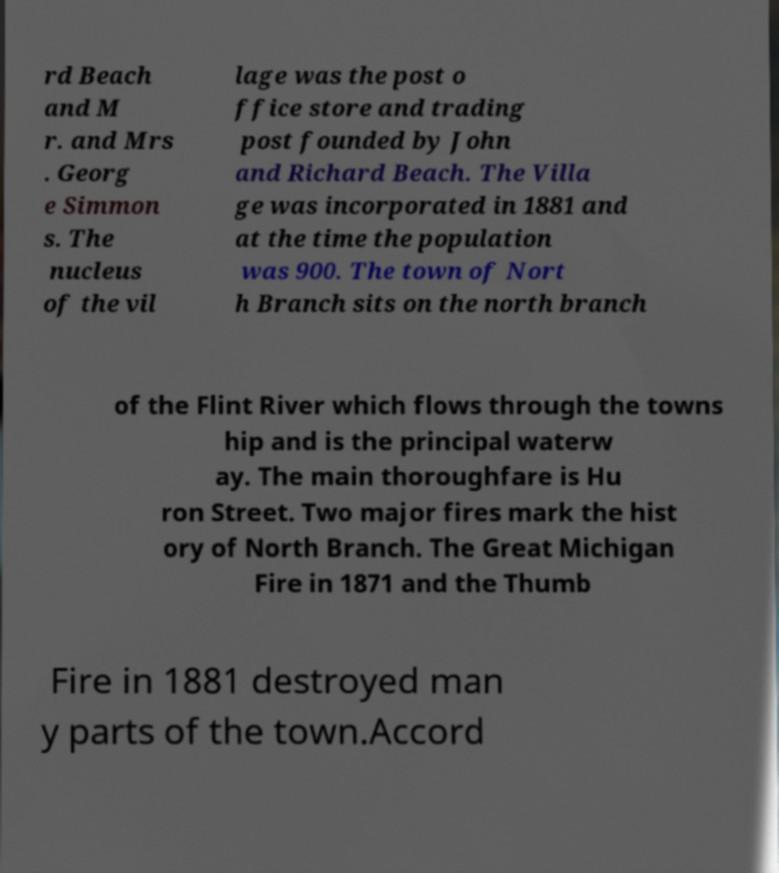Please identify and transcribe the text found in this image. rd Beach and M r. and Mrs . Georg e Simmon s. The nucleus of the vil lage was the post o ffice store and trading post founded by John and Richard Beach. The Villa ge was incorporated in 1881 and at the time the population was 900. The town of Nort h Branch sits on the north branch of the Flint River which flows through the towns hip and is the principal waterw ay. The main thoroughfare is Hu ron Street. Two major fires mark the hist ory of North Branch. The Great Michigan Fire in 1871 and the Thumb Fire in 1881 destroyed man y parts of the town.Accord 